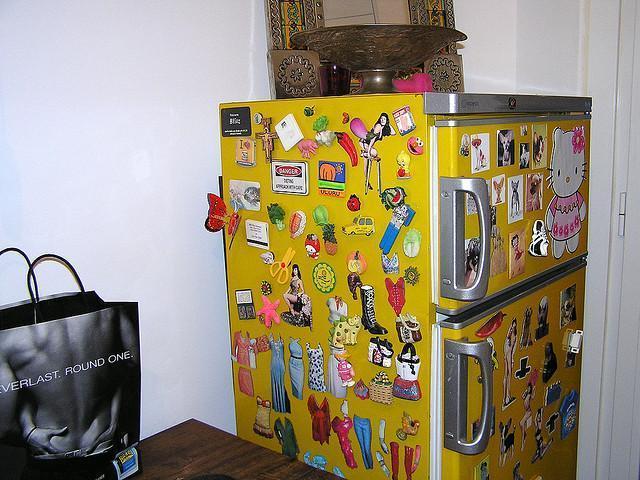How many doors are on the fridge?
Give a very brief answer. 2. 